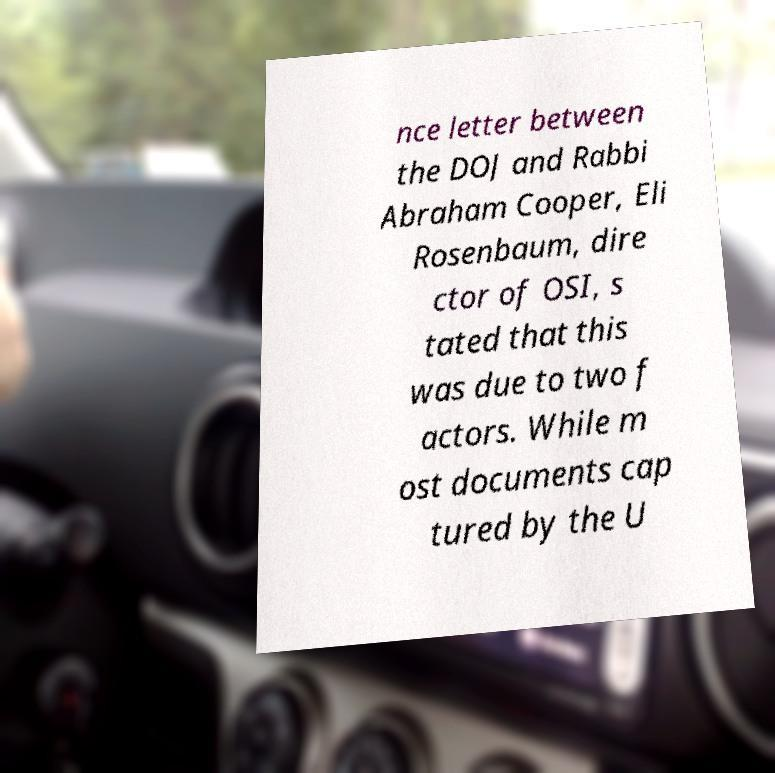Can you read and provide the text displayed in the image?This photo seems to have some interesting text. Can you extract and type it out for me? nce letter between the DOJ and Rabbi Abraham Cooper, Eli Rosenbaum, dire ctor of OSI, s tated that this was due to two f actors. While m ost documents cap tured by the U 